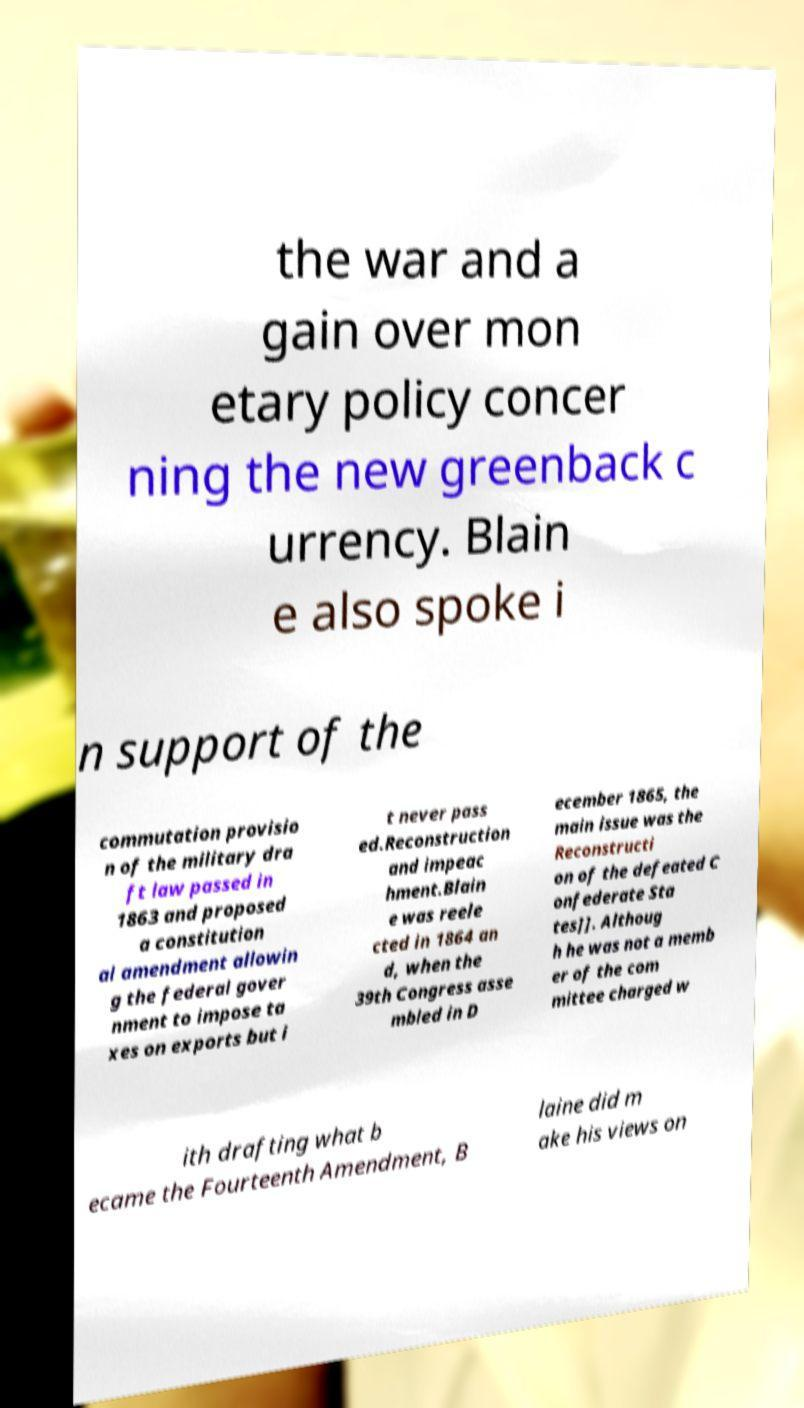Please read and relay the text visible in this image. What does it say? the war and a gain over mon etary policy concer ning the new greenback c urrency. Blain e also spoke i n support of the commutation provisio n of the military dra ft law passed in 1863 and proposed a constitution al amendment allowin g the federal gover nment to impose ta xes on exports but i t never pass ed.Reconstruction and impeac hment.Blain e was reele cted in 1864 an d, when the 39th Congress asse mbled in D ecember 1865, the main issue was the Reconstructi on of the defeated C onfederate Sta tes]]. Althoug h he was not a memb er of the com mittee charged w ith drafting what b ecame the Fourteenth Amendment, B laine did m ake his views on 